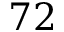Convert formula to latex. <formula><loc_0><loc_0><loc_500><loc_500>7 2</formula> 